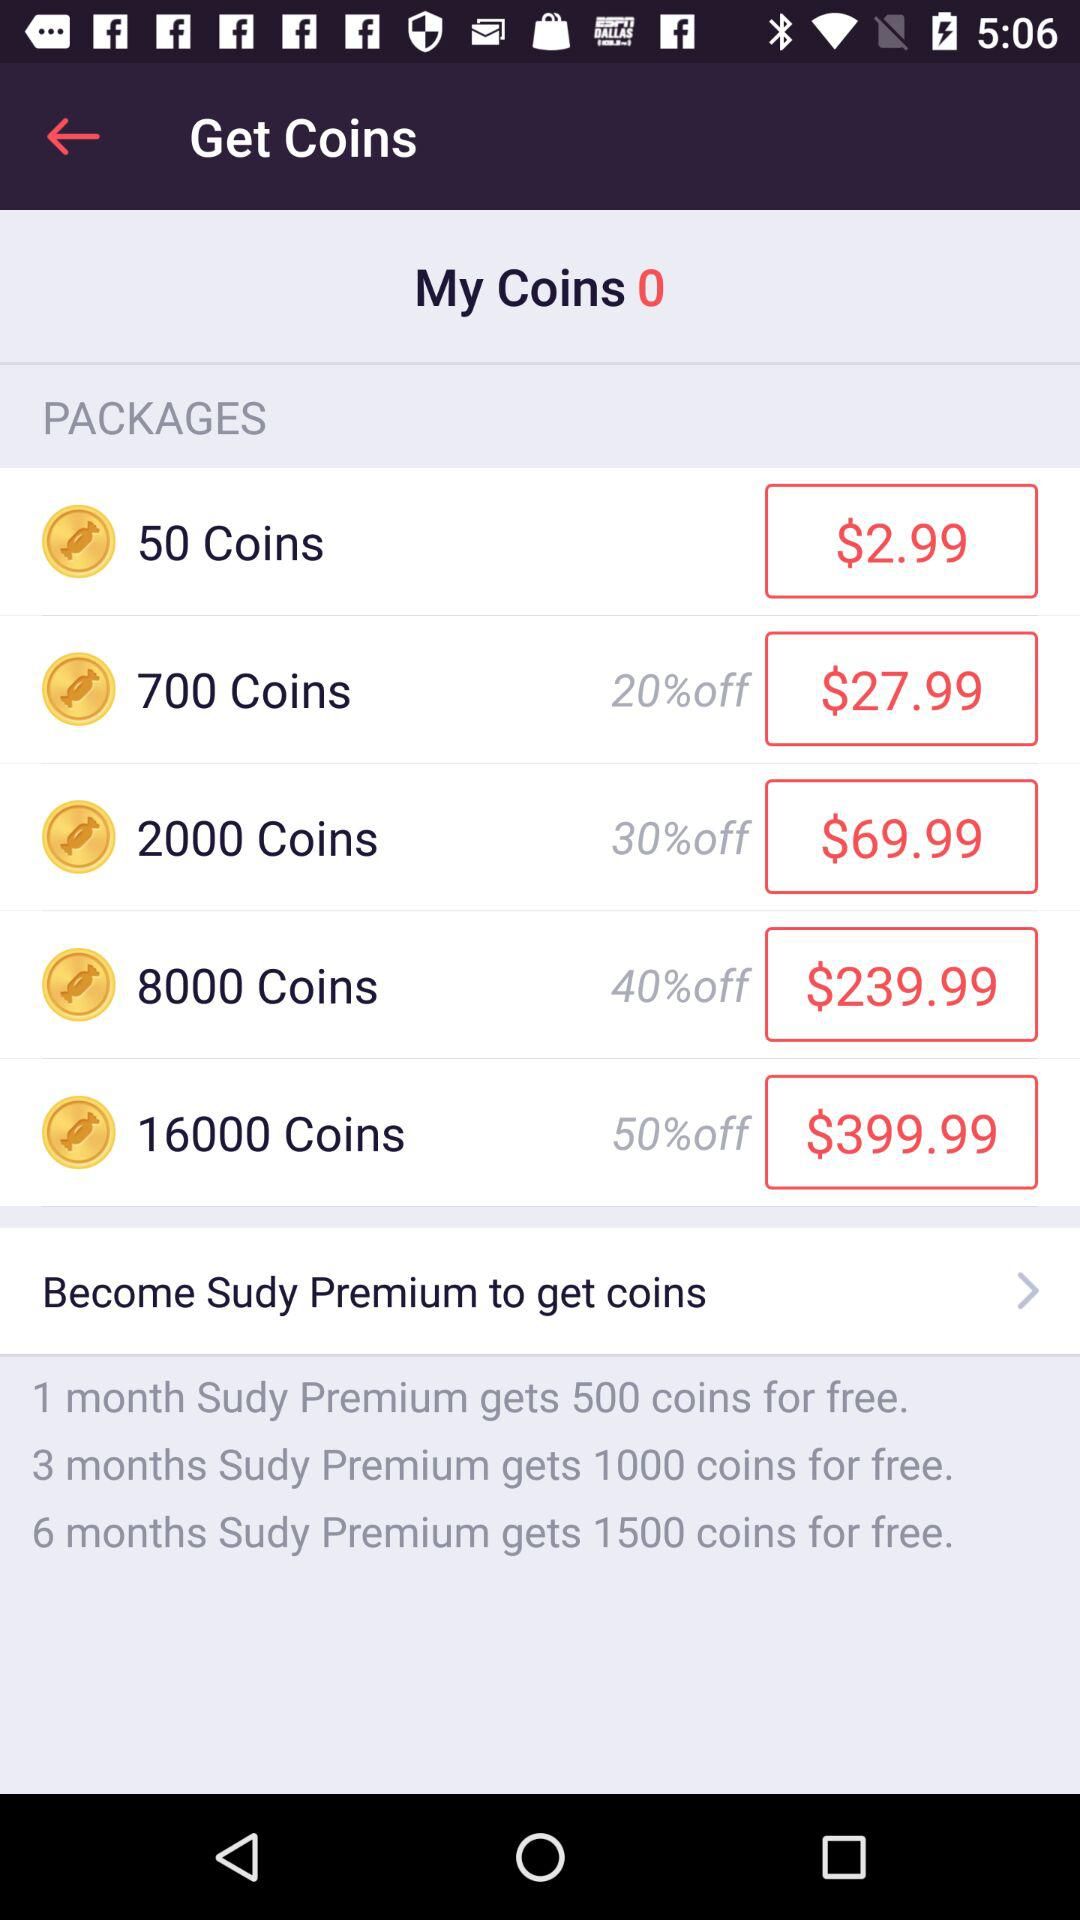What's the price for 700 coins? The price is $27.99. 